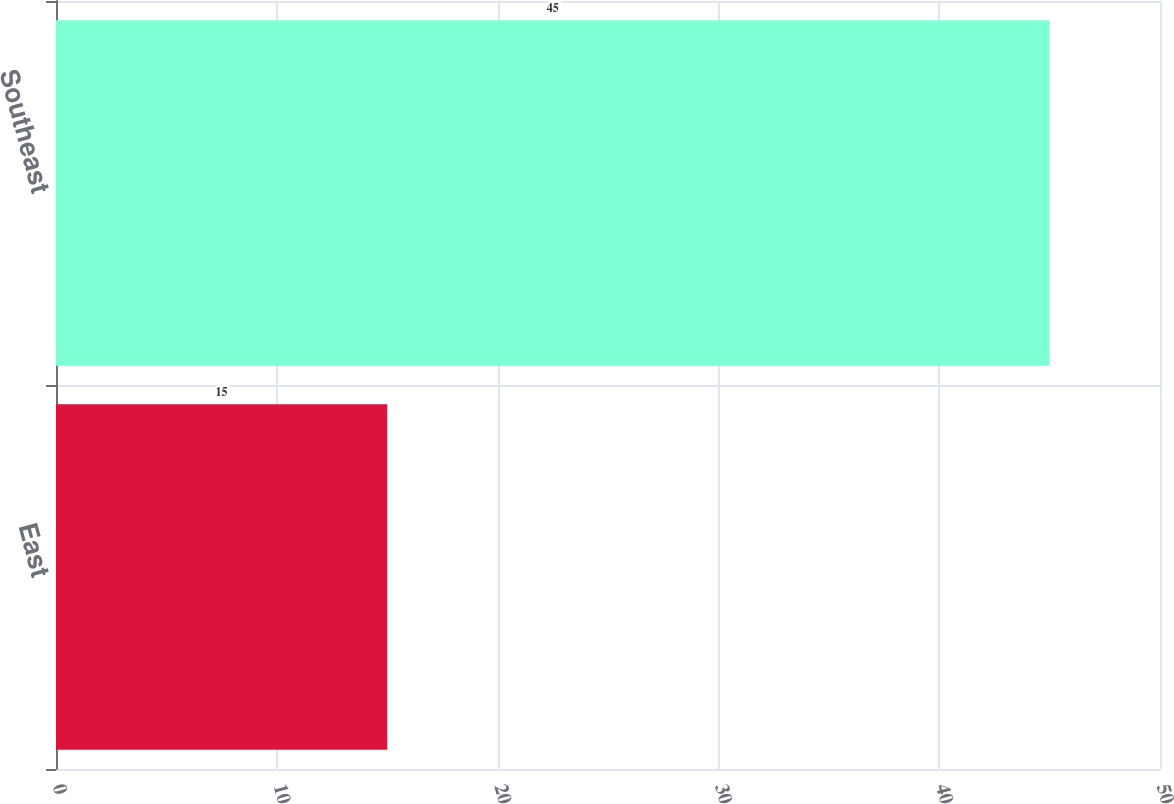<chart> <loc_0><loc_0><loc_500><loc_500><bar_chart><fcel>East<fcel>Southeast<nl><fcel>15<fcel>45<nl></chart> 